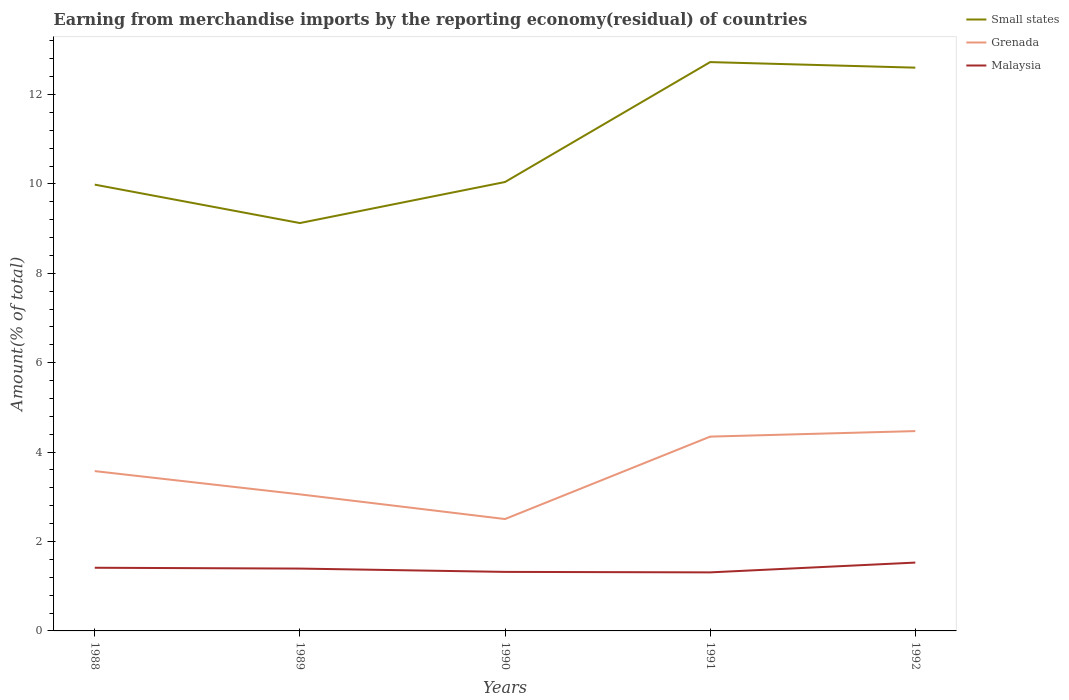Does the line corresponding to Malaysia intersect with the line corresponding to Small states?
Give a very brief answer. No. Across all years, what is the maximum percentage of amount earned from merchandise imports in Malaysia?
Offer a very short reply. 1.31. What is the total percentage of amount earned from merchandise imports in Malaysia in the graph?
Ensure brevity in your answer.  -0.22. What is the difference between the highest and the second highest percentage of amount earned from merchandise imports in Grenada?
Provide a short and direct response. 1.97. Is the percentage of amount earned from merchandise imports in Malaysia strictly greater than the percentage of amount earned from merchandise imports in Small states over the years?
Ensure brevity in your answer.  Yes. How many lines are there?
Your answer should be very brief. 3. Does the graph contain grids?
Offer a terse response. No. How many legend labels are there?
Keep it short and to the point. 3. How are the legend labels stacked?
Your answer should be very brief. Vertical. What is the title of the graph?
Ensure brevity in your answer.  Earning from merchandise imports by the reporting economy(residual) of countries. What is the label or title of the X-axis?
Offer a terse response. Years. What is the label or title of the Y-axis?
Your answer should be very brief. Amount(% of total). What is the Amount(% of total) in Small states in 1988?
Keep it short and to the point. 9.98. What is the Amount(% of total) of Grenada in 1988?
Ensure brevity in your answer.  3.58. What is the Amount(% of total) in Malaysia in 1988?
Provide a short and direct response. 1.41. What is the Amount(% of total) of Small states in 1989?
Provide a succinct answer. 9.12. What is the Amount(% of total) in Grenada in 1989?
Provide a short and direct response. 3.06. What is the Amount(% of total) in Malaysia in 1989?
Your response must be concise. 1.39. What is the Amount(% of total) in Small states in 1990?
Ensure brevity in your answer.  10.04. What is the Amount(% of total) of Grenada in 1990?
Your answer should be very brief. 2.5. What is the Amount(% of total) of Malaysia in 1990?
Ensure brevity in your answer.  1.32. What is the Amount(% of total) in Small states in 1991?
Ensure brevity in your answer.  12.72. What is the Amount(% of total) in Grenada in 1991?
Offer a terse response. 4.35. What is the Amount(% of total) of Malaysia in 1991?
Offer a very short reply. 1.31. What is the Amount(% of total) in Small states in 1992?
Keep it short and to the point. 12.6. What is the Amount(% of total) in Grenada in 1992?
Provide a succinct answer. 4.47. What is the Amount(% of total) in Malaysia in 1992?
Your answer should be compact. 1.53. Across all years, what is the maximum Amount(% of total) of Small states?
Provide a succinct answer. 12.72. Across all years, what is the maximum Amount(% of total) in Grenada?
Make the answer very short. 4.47. Across all years, what is the maximum Amount(% of total) of Malaysia?
Provide a succinct answer. 1.53. Across all years, what is the minimum Amount(% of total) in Small states?
Offer a terse response. 9.12. Across all years, what is the minimum Amount(% of total) in Grenada?
Provide a short and direct response. 2.5. Across all years, what is the minimum Amount(% of total) of Malaysia?
Your answer should be compact. 1.31. What is the total Amount(% of total) of Small states in the graph?
Keep it short and to the point. 54.47. What is the total Amount(% of total) of Grenada in the graph?
Ensure brevity in your answer.  17.95. What is the total Amount(% of total) of Malaysia in the graph?
Your response must be concise. 6.97. What is the difference between the Amount(% of total) of Small states in 1988 and that in 1989?
Offer a terse response. 0.86. What is the difference between the Amount(% of total) of Grenada in 1988 and that in 1989?
Provide a short and direct response. 0.52. What is the difference between the Amount(% of total) of Malaysia in 1988 and that in 1989?
Give a very brief answer. 0.02. What is the difference between the Amount(% of total) of Small states in 1988 and that in 1990?
Offer a terse response. -0.06. What is the difference between the Amount(% of total) in Grenada in 1988 and that in 1990?
Provide a succinct answer. 1.07. What is the difference between the Amount(% of total) of Malaysia in 1988 and that in 1990?
Give a very brief answer. 0.09. What is the difference between the Amount(% of total) of Small states in 1988 and that in 1991?
Provide a succinct answer. -2.74. What is the difference between the Amount(% of total) of Grenada in 1988 and that in 1991?
Offer a terse response. -0.77. What is the difference between the Amount(% of total) in Malaysia in 1988 and that in 1991?
Make the answer very short. 0.1. What is the difference between the Amount(% of total) in Small states in 1988 and that in 1992?
Provide a short and direct response. -2.62. What is the difference between the Amount(% of total) of Grenada in 1988 and that in 1992?
Ensure brevity in your answer.  -0.9. What is the difference between the Amount(% of total) of Malaysia in 1988 and that in 1992?
Give a very brief answer. -0.12. What is the difference between the Amount(% of total) of Small states in 1989 and that in 1990?
Your answer should be very brief. -0.92. What is the difference between the Amount(% of total) in Grenada in 1989 and that in 1990?
Your answer should be very brief. 0.55. What is the difference between the Amount(% of total) in Malaysia in 1989 and that in 1990?
Make the answer very short. 0.07. What is the difference between the Amount(% of total) in Small states in 1989 and that in 1991?
Your answer should be very brief. -3.6. What is the difference between the Amount(% of total) of Grenada in 1989 and that in 1991?
Ensure brevity in your answer.  -1.29. What is the difference between the Amount(% of total) of Malaysia in 1989 and that in 1991?
Keep it short and to the point. 0.09. What is the difference between the Amount(% of total) of Small states in 1989 and that in 1992?
Ensure brevity in your answer.  -3.48. What is the difference between the Amount(% of total) of Grenada in 1989 and that in 1992?
Ensure brevity in your answer.  -1.42. What is the difference between the Amount(% of total) in Malaysia in 1989 and that in 1992?
Provide a succinct answer. -0.13. What is the difference between the Amount(% of total) of Small states in 1990 and that in 1991?
Offer a very short reply. -2.68. What is the difference between the Amount(% of total) in Grenada in 1990 and that in 1991?
Provide a short and direct response. -1.84. What is the difference between the Amount(% of total) in Malaysia in 1990 and that in 1991?
Keep it short and to the point. 0.01. What is the difference between the Amount(% of total) in Small states in 1990 and that in 1992?
Offer a terse response. -2.56. What is the difference between the Amount(% of total) in Grenada in 1990 and that in 1992?
Make the answer very short. -1.97. What is the difference between the Amount(% of total) of Malaysia in 1990 and that in 1992?
Ensure brevity in your answer.  -0.21. What is the difference between the Amount(% of total) in Small states in 1991 and that in 1992?
Ensure brevity in your answer.  0.12. What is the difference between the Amount(% of total) in Grenada in 1991 and that in 1992?
Ensure brevity in your answer.  -0.12. What is the difference between the Amount(% of total) of Malaysia in 1991 and that in 1992?
Give a very brief answer. -0.22. What is the difference between the Amount(% of total) of Small states in 1988 and the Amount(% of total) of Grenada in 1989?
Your answer should be compact. 6.93. What is the difference between the Amount(% of total) in Small states in 1988 and the Amount(% of total) in Malaysia in 1989?
Your answer should be compact. 8.59. What is the difference between the Amount(% of total) of Grenada in 1988 and the Amount(% of total) of Malaysia in 1989?
Your answer should be compact. 2.18. What is the difference between the Amount(% of total) of Small states in 1988 and the Amount(% of total) of Grenada in 1990?
Keep it short and to the point. 7.48. What is the difference between the Amount(% of total) of Small states in 1988 and the Amount(% of total) of Malaysia in 1990?
Make the answer very short. 8.66. What is the difference between the Amount(% of total) of Grenada in 1988 and the Amount(% of total) of Malaysia in 1990?
Make the answer very short. 2.25. What is the difference between the Amount(% of total) of Small states in 1988 and the Amount(% of total) of Grenada in 1991?
Give a very brief answer. 5.64. What is the difference between the Amount(% of total) in Small states in 1988 and the Amount(% of total) in Malaysia in 1991?
Keep it short and to the point. 8.67. What is the difference between the Amount(% of total) in Grenada in 1988 and the Amount(% of total) in Malaysia in 1991?
Provide a short and direct response. 2.27. What is the difference between the Amount(% of total) of Small states in 1988 and the Amount(% of total) of Grenada in 1992?
Give a very brief answer. 5.51. What is the difference between the Amount(% of total) of Small states in 1988 and the Amount(% of total) of Malaysia in 1992?
Your answer should be compact. 8.45. What is the difference between the Amount(% of total) in Grenada in 1988 and the Amount(% of total) in Malaysia in 1992?
Your answer should be very brief. 2.05. What is the difference between the Amount(% of total) in Small states in 1989 and the Amount(% of total) in Grenada in 1990?
Provide a succinct answer. 6.62. What is the difference between the Amount(% of total) of Small states in 1989 and the Amount(% of total) of Malaysia in 1990?
Keep it short and to the point. 7.8. What is the difference between the Amount(% of total) in Grenada in 1989 and the Amount(% of total) in Malaysia in 1990?
Provide a succinct answer. 1.73. What is the difference between the Amount(% of total) of Small states in 1989 and the Amount(% of total) of Grenada in 1991?
Make the answer very short. 4.78. What is the difference between the Amount(% of total) of Small states in 1989 and the Amount(% of total) of Malaysia in 1991?
Offer a terse response. 7.81. What is the difference between the Amount(% of total) in Grenada in 1989 and the Amount(% of total) in Malaysia in 1991?
Keep it short and to the point. 1.75. What is the difference between the Amount(% of total) in Small states in 1989 and the Amount(% of total) in Grenada in 1992?
Make the answer very short. 4.65. What is the difference between the Amount(% of total) in Small states in 1989 and the Amount(% of total) in Malaysia in 1992?
Provide a succinct answer. 7.6. What is the difference between the Amount(% of total) of Grenada in 1989 and the Amount(% of total) of Malaysia in 1992?
Offer a very short reply. 1.53. What is the difference between the Amount(% of total) in Small states in 1990 and the Amount(% of total) in Grenada in 1991?
Give a very brief answer. 5.7. What is the difference between the Amount(% of total) of Small states in 1990 and the Amount(% of total) of Malaysia in 1991?
Give a very brief answer. 8.73. What is the difference between the Amount(% of total) of Grenada in 1990 and the Amount(% of total) of Malaysia in 1991?
Your answer should be compact. 1.19. What is the difference between the Amount(% of total) in Small states in 1990 and the Amount(% of total) in Grenada in 1992?
Keep it short and to the point. 5.57. What is the difference between the Amount(% of total) in Small states in 1990 and the Amount(% of total) in Malaysia in 1992?
Your answer should be compact. 8.51. What is the difference between the Amount(% of total) in Grenada in 1990 and the Amount(% of total) in Malaysia in 1992?
Your response must be concise. 0.97. What is the difference between the Amount(% of total) in Small states in 1991 and the Amount(% of total) in Grenada in 1992?
Provide a succinct answer. 8.25. What is the difference between the Amount(% of total) of Small states in 1991 and the Amount(% of total) of Malaysia in 1992?
Make the answer very short. 11.2. What is the difference between the Amount(% of total) in Grenada in 1991 and the Amount(% of total) in Malaysia in 1992?
Ensure brevity in your answer.  2.82. What is the average Amount(% of total) in Small states per year?
Give a very brief answer. 10.89. What is the average Amount(% of total) in Grenada per year?
Provide a succinct answer. 3.59. What is the average Amount(% of total) in Malaysia per year?
Keep it short and to the point. 1.39. In the year 1988, what is the difference between the Amount(% of total) of Small states and Amount(% of total) of Grenada?
Give a very brief answer. 6.41. In the year 1988, what is the difference between the Amount(% of total) of Small states and Amount(% of total) of Malaysia?
Provide a succinct answer. 8.57. In the year 1988, what is the difference between the Amount(% of total) of Grenada and Amount(% of total) of Malaysia?
Provide a succinct answer. 2.16. In the year 1989, what is the difference between the Amount(% of total) in Small states and Amount(% of total) in Grenada?
Give a very brief answer. 6.07. In the year 1989, what is the difference between the Amount(% of total) of Small states and Amount(% of total) of Malaysia?
Your answer should be compact. 7.73. In the year 1989, what is the difference between the Amount(% of total) of Grenada and Amount(% of total) of Malaysia?
Give a very brief answer. 1.66. In the year 1990, what is the difference between the Amount(% of total) of Small states and Amount(% of total) of Grenada?
Offer a terse response. 7.54. In the year 1990, what is the difference between the Amount(% of total) in Small states and Amount(% of total) in Malaysia?
Provide a short and direct response. 8.72. In the year 1990, what is the difference between the Amount(% of total) in Grenada and Amount(% of total) in Malaysia?
Offer a terse response. 1.18. In the year 1991, what is the difference between the Amount(% of total) of Small states and Amount(% of total) of Grenada?
Ensure brevity in your answer.  8.38. In the year 1991, what is the difference between the Amount(% of total) of Small states and Amount(% of total) of Malaysia?
Your answer should be compact. 11.41. In the year 1991, what is the difference between the Amount(% of total) of Grenada and Amount(% of total) of Malaysia?
Provide a succinct answer. 3.04. In the year 1992, what is the difference between the Amount(% of total) of Small states and Amount(% of total) of Grenada?
Your response must be concise. 8.13. In the year 1992, what is the difference between the Amount(% of total) in Small states and Amount(% of total) in Malaysia?
Your response must be concise. 11.07. In the year 1992, what is the difference between the Amount(% of total) of Grenada and Amount(% of total) of Malaysia?
Offer a terse response. 2.94. What is the ratio of the Amount(% of total) of Small states in 1988 to that in 1989?
Provide a short and direct response. 1.09. What is the ratio of the Amount(% of total) in Grenada in 1988 to that in 1989?
Provide a short and direct response. 1.17. What is the ratio of the Amount(% of total) in Malaysia in 1988 to that in 1989?
Your response must be concise. 1.01. What is the ratio of the Amount(% of total) in Grenada in 1988 to that in 1990?
Provide a short and direct response. 1.43. What is the ratio of the Amount(% of total) in Malaysia in 1988 to that in 1990?
Your answer should be very brief. 1.07. What is the ratio of the Amount(% of total) of Small states in 1988 to that in 1991?
Provide a short and direct response. 0.78. What is the ratio of the Amount(% of total) in Grenada in 1988 to that in 1991?
Offer a very short reply. 0.82. What is the ratio of the Amount(% of total) of Malaysia in 1988 to that in 1991?
Keep it short and to the point. 1.08. What is the ratio of the Amount(% of total) of Small states in 1988 to that in 1992?
Provide a short and direct response. 0.79. What is the ratio of the Amount(% of total) of Grenada in 1988 to that in 1992?
Keep it short and to the point. 0.8. What is the ratio of the Amount(% of total) of Malaysia in 1988 to that in 1992?
Your answer should be very brief. 0.92. What is the ratio of the Amount(% of total) in Small states in 1989 to that in 1990?
Provide a succinct answer. 0.91. What is the ratio of the Amount(% of total) in Grenada in 1989 to that in 1990?
Your answer should be compact. 1.22. What is the ratio of the Amount(% of total) in Malaysia in 1989 to that in 1990?
Your answer should be compact. 1.06. What is the ratio of the Amount(% of total) in Small states in 1989 to that in 1991?
Your response must be concise. 0.72. What is the ratio of the Amount(% of total) in Grenada in 1989 to that in 1991?
Provide a succinct answer. 0.7. What is the ratio of the Amount(% of total) of Malaysia in 1989 to that in 1991?
Your response must be concise. 1.06. What is the ratio of the Amount(% of total) of Small states in 1989 to that in 1992?
Provide a succinct answer. 0.72. What is the ratio of the Amount(% of total) of Grenada in 1989 to that in 1992?
Keep it short and to the point. 0.68. What is the ratio of the Amount(% of total) of Malaysia in 1989 to that in 1992?
Offer a terse response. 0.91. What is the ratio of the Amount(% of total) in Small states in 1990 to that in 1991?
Your answer should be compact. 0.79. What is the ratio of the Amount(% of total) in Grenada in 1990 to that in 1991?
Keep it short and to the point. 0.58. What is the ratio of the Amount(% of total) of Malaysia in 1990 to that in 1991?
Your response must be concise. 1.01. What is the ratio of the Amount(% of total) in Small states in 1990 to that in 1992?
Offer a very short reply. 0.8. What is the ratio of the Amount(% of total) of Grenada in 1990 to that in 1992?
Provide a short and direct response. 0.56. What is the ratio of the Amount(% of total) of Malaysia in 1990 to that in 1992?
Make the answer very short. 0.86. What is the ratio of the Amount(% of total) of Small states in 1991 to that in 1992?
Your response must be concise. 1.01. What is the ratio of the Amount(% of total) of Grenada in 1991 to that in 1992?
Your response must be concise. 0.97. What is the ratio of the Amount(% of total) of Malaysia in 1991 to that in 1992?
Provide a short and direct response. 0.86. What is the difference between the highest and the second highest Amount(% of total) of Small states?
Provide a short and direct response. 0.12. What is the difference between the highest and the second highest Amount(% of total) in Grenada?
Your response must be concise. 0.12. What is the difference between the highest and the second highest Amount(% of total) of Malaysia?
Your answer should be compact. 0.12. What is the difference between the highest and the lowest Amount(% of total) of Small states?
Your answer should be compact. 3.6. What is the difference between the highest and the lowest Amount(% of total) of Grenada?
Offer a very short reply. 1.97. What is the difference between the highest and the lowest Amount(% of total) of Malaysia?
Your response must be concise. 0.22. 